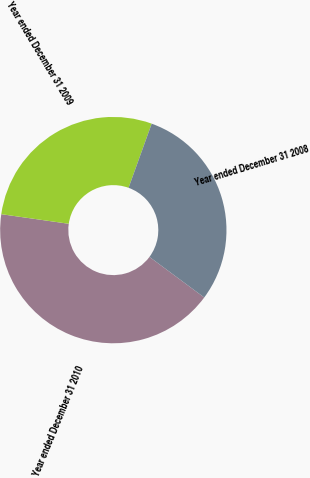<chart> <loc_0><loc_0><loc_500><loc_500><pie_chart><fcel>Year ended December 31 2010<fcel>Year ended December 31 2009<fcel>Year ended December 31 2008<nl><fcel>42.1%<fcel>28.26%<fcel>29.64%<nl></chart> 